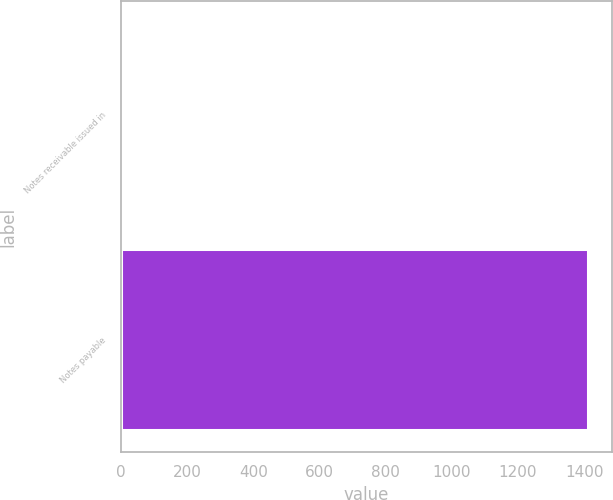Convert chart to OTSL. <chart><loc_0><loc_0><loc_500><loc_500><bar_chart><fcel>Notes receivable issued in<fcel>Notes payable<nl><fcel>2.8<fcel>1412.5<nl></chart> 